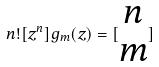<formula> <loc_0><loc_0><loc_500><loc_500>n ! [ z ^ { n } ] g _ { m } ( z ) = [ \begin{matrix} n \\ m \end{matrix} ]</formula> 